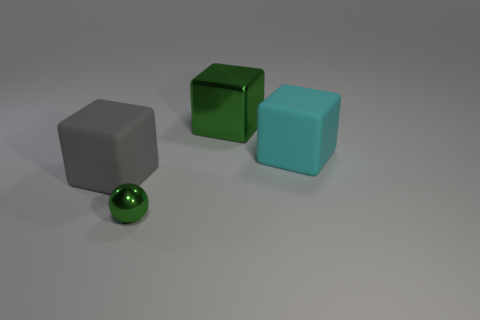Is the number of rubber cubes that are in front of the metallic ball the same as the number of large gray rubber cubes?
Offer a very short reply. No. What is the size of the block that is both left of the large cyan object and to the right of the gray block?
Your response must be concise. Large. The object in front of the matte object to the left of the large metal thing is what color?
Provide a short and direct response. Green. What number of green things are rubber blocks or metal blocks?
Your answer should be compact. 1. What is the color of the large object that is both in front of the large green block and behind the gray rubber block?
Your response must be concise. Cyan. What number of big objects are green cylinders or green shiny blocks?
Provide a succinct answer. 1. What size is the gray object that is the same shape as the cyan object?
Provide a succinct answer. Large. The gray matte thing has what shape?
Provide a short and direct response. Cube. Is the green ball made of the same material as the large block to the left of the tiny green sphere?
Give a very brief answer. No. What number of rubber objects are either cubes or large gray blocks?
Provide a short and direct response. 2. 